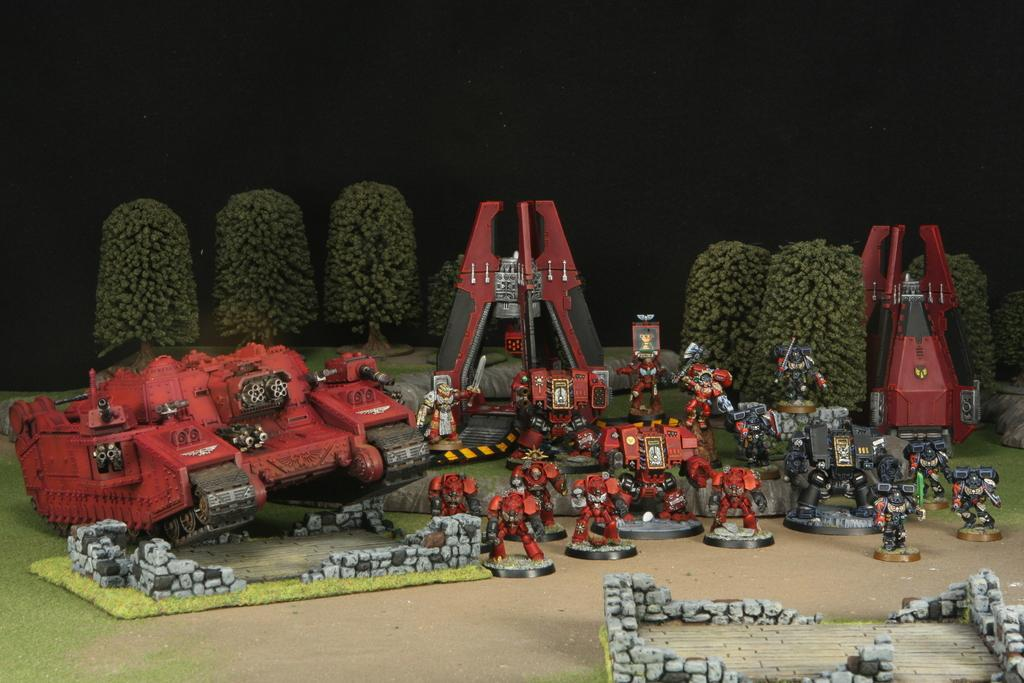What objects can be seen in the image? There are toys in the image. What can be observed about the lighting in the image? The background of the image is dark. What type of apparatus is being used by the goose in the image? There is no goose or apparatus present in the image. How many brothers are visible in the image? There is no reference to any brothers in the image. 